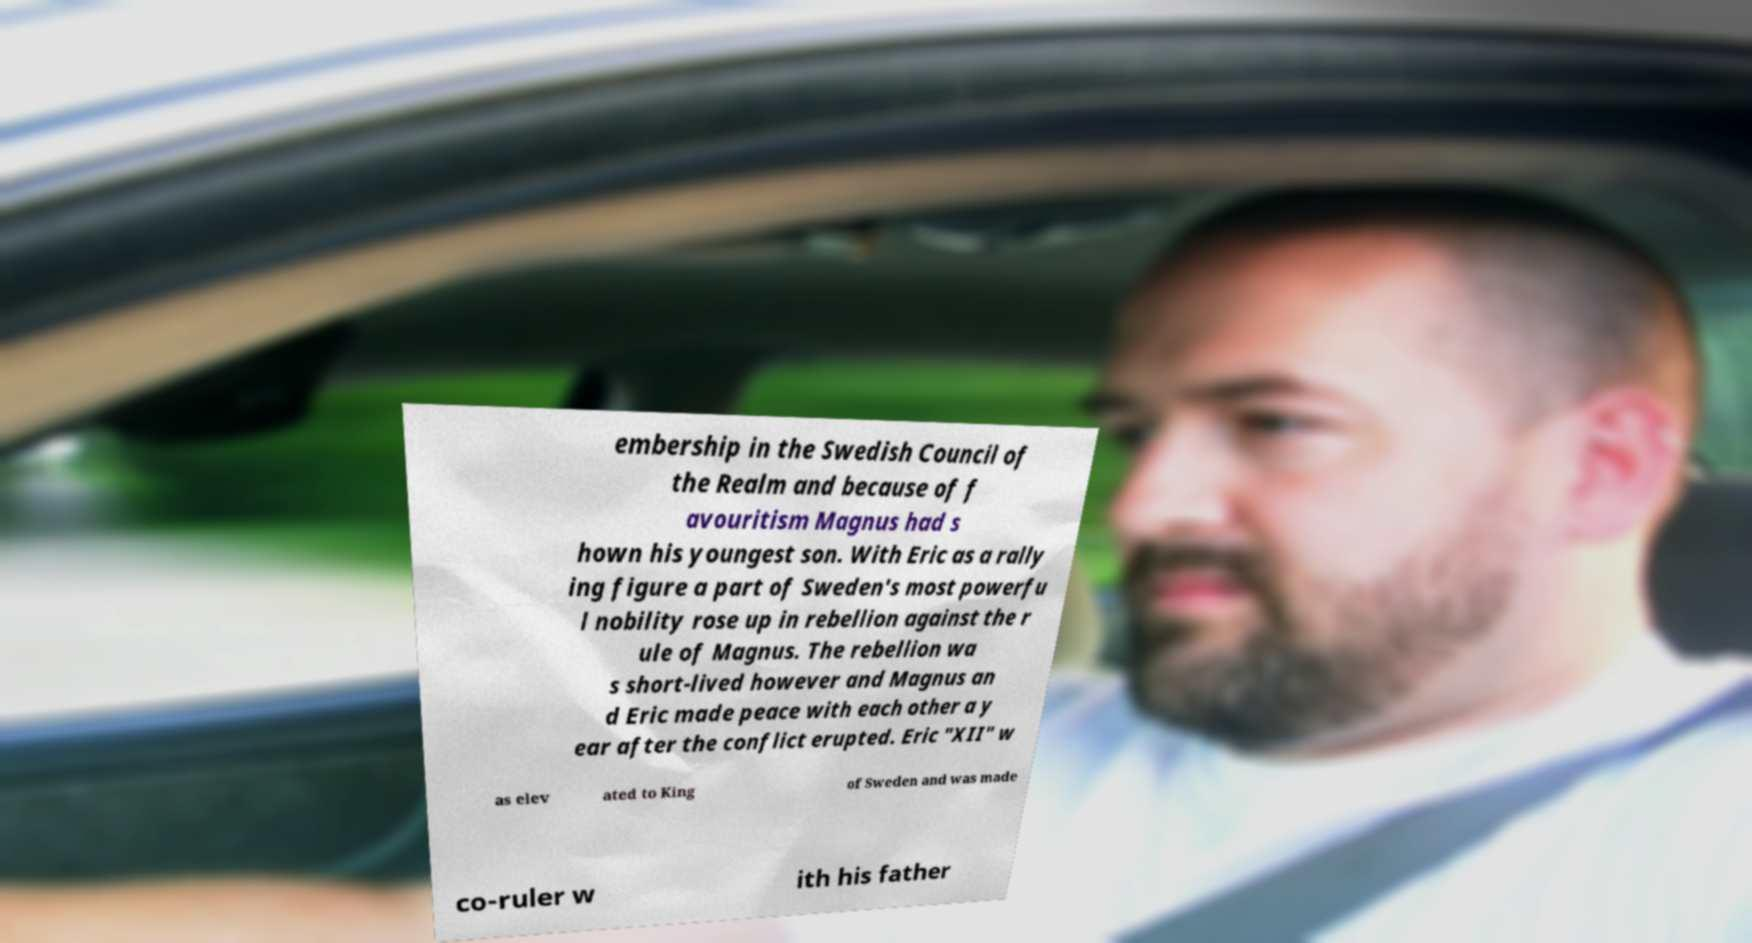There's text embedded in this image that I need extracted. Can you transcribe it verbatim? embership in the Swedish Council of the Realm and because of f avouritism Magnus had s hown his youngest son. With Eric as a rally ing figure a part of Sweden's most powerfu l nobility rose up in rebellion against the r ule of Magnus. The rebellion wa s short-lived however and Magnus an d Eric made peace with each other a y ear after the conflict erupted. Eric "XII" w as elev ated to King of Sweden and was made co-ruler w ith his father 